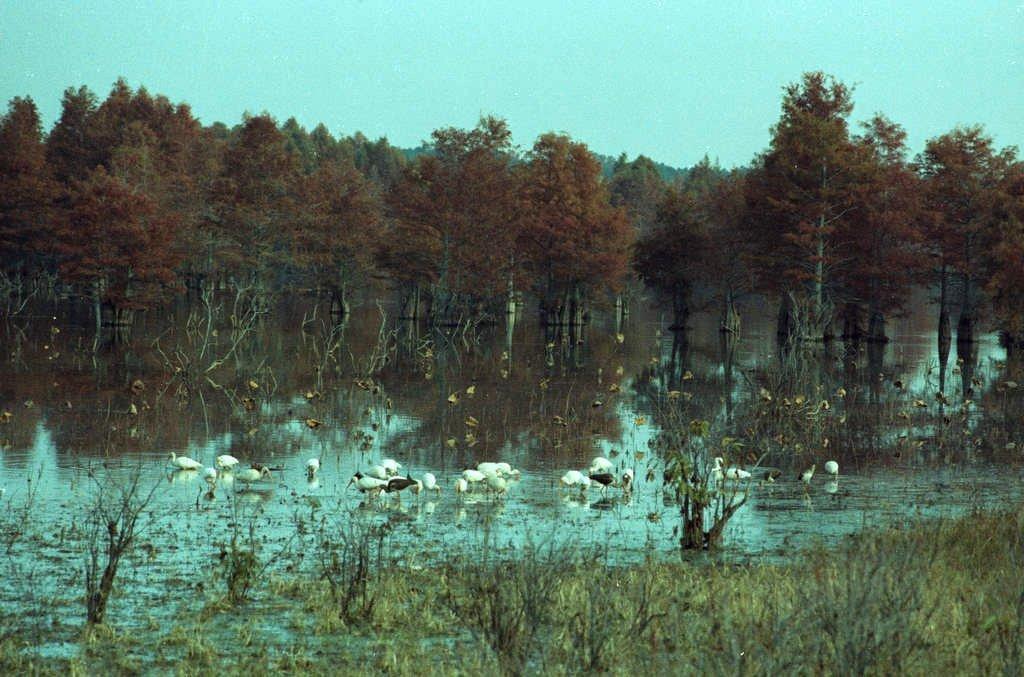In one or two sentences, can you explain what this image depicts? In this image we can see the birds on the surface of the water. We can also see the grass, trees and also the sky at the top. 